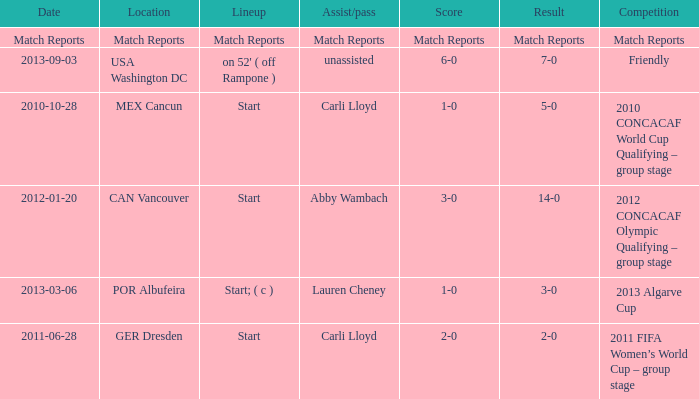Which score has a competition of match reports? Match Reports. Help me parse the entirety of this table. {'header': ['Date', 'Location', 'Lineup', 'Assist/pass', 'Score', 'Result', 'Competition'], 'rows': [['Match Reports', 'Match Reports', 'Match Reports', 'Match Reports', 'Match Reports', 'Match Reports', 'Match Reports'], ['2013-09-03', 'USA Washington DC', "on 52' ( off Rampone )", 'unassisted', '6-0', '7-0', 'Friendly'], ['2010-10-28', 'MEX Cancun', 'Start', 'Carli Lloyd', '1-0', '5-0', '2010 CONCACAF World Cup Qualifying – group stage'], ['2012-01-20', 'CAN Vancouver', 'Start', 'Abby Wambach', '3-0', '14-0', '2012 CONCACAF Olympic Qualifying – group stage'], ['2013-03-06', 'POR Albufeira', 'Start; ( c )', 'Lauren Cheney', '1-0', '3-0', '2013 Algarve Cup'], ['2011-06-28', 'GER Dresden', 'Start', 'Carli Lloyd', '2-0', '2-0', '2011 FIFA Women’s World Cup – group stage']]} 